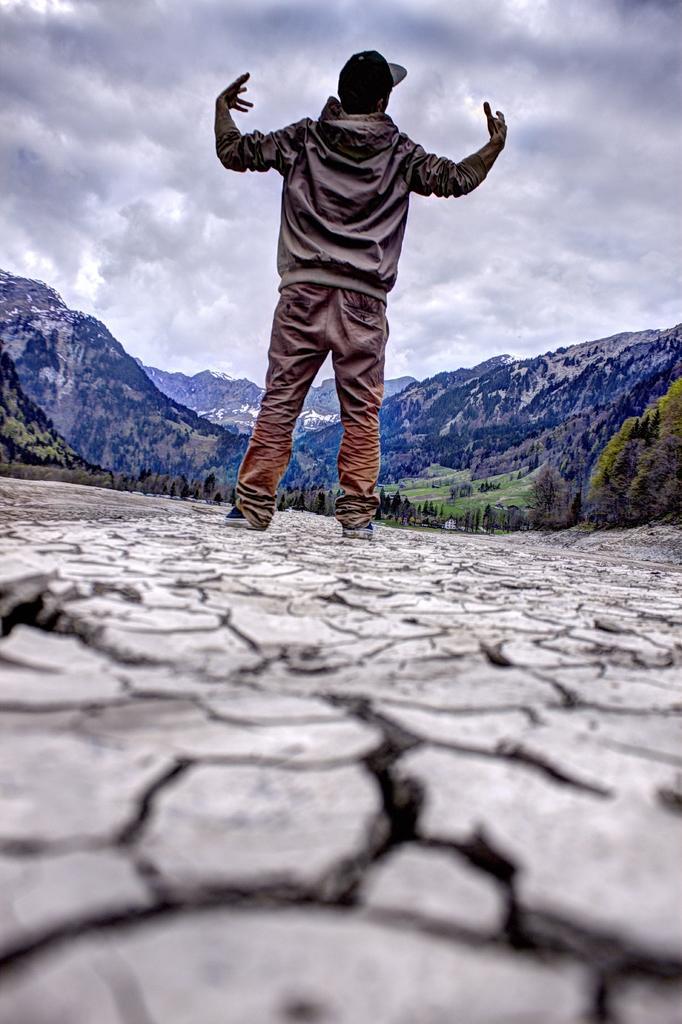In one or two sentences, can you explain what this image depicts? In this image we can see the mountains, one man with black cap standing on the ground, one white object on the ground, some trees, bushes and grass on the ground. At the top there is the cloudy sky. 